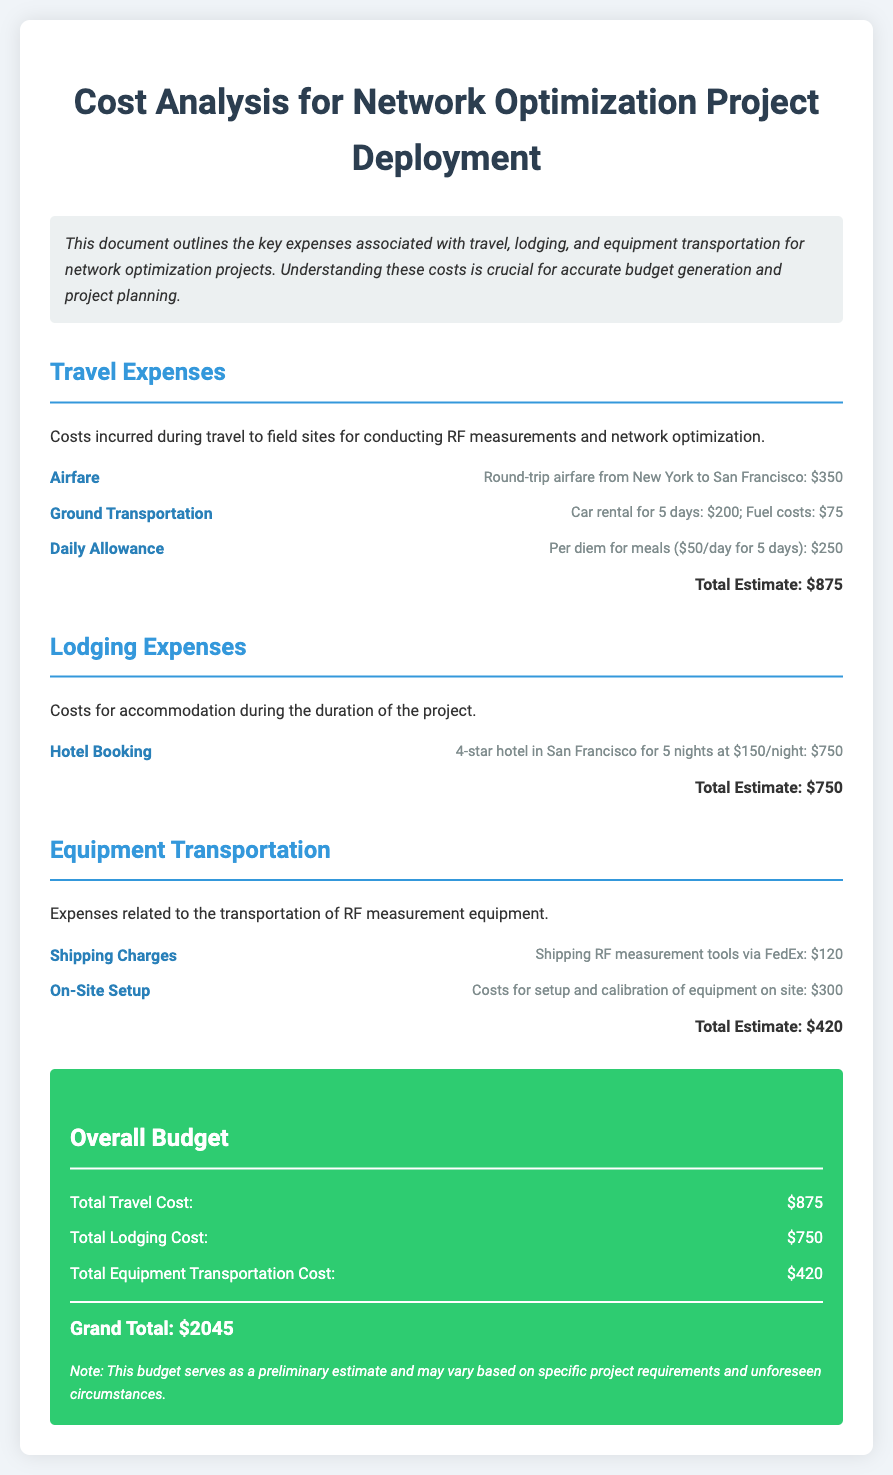What is the total travel cost? The total travel cost is detailed in the travel expenses section of the document, which sums to $875.
Answer: $875 What is the daily allowance per day? The daily allowance per day for meals is stated as $50, calculated over 5 days.
Answer: $50 What is the cost of hotel booking? The hotel booking cost is specified as $150 per night for 5 nights, totaling $750.
Answer: $750 What is the grand total cost for the project? The grand total is the sum of all expenses calculated in the overall budget section, amounting to $2045.
Answer: $2045 How much is allocated for shipping charges? The shipping charges for transporting RF measurement tools are provided as $120 in the equipment transportation section.
Answer: $120 What type of document is this? The document is a budget outlining the costs associated with network optimization project deployment.
Answer: Budget What is the total lodging cost? The total lodging cost is indicated separately in the overall budget section, which totals $750.
Answer: $750 How many days was the car rented? The car was rented for a duration stated as 5 days in the travel expenses details.
Answer: 5 days 